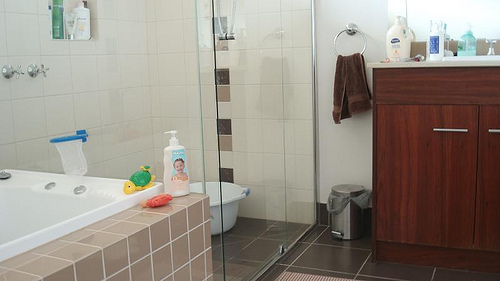How would you use this bathroom if you were preparing for an important event? I would start by organizing the toiletries on the counter for easy access. Next, I would ensure that the shower area is clean and prepared, with my favorite scented soap and shampoo. Additionally, I’d place fresh towels around and maybe light a calming scented candle to set the mood. After a refreshing shower, I would use the mirror and counter space to do my grooming routine, making sure I look my best for the event. 